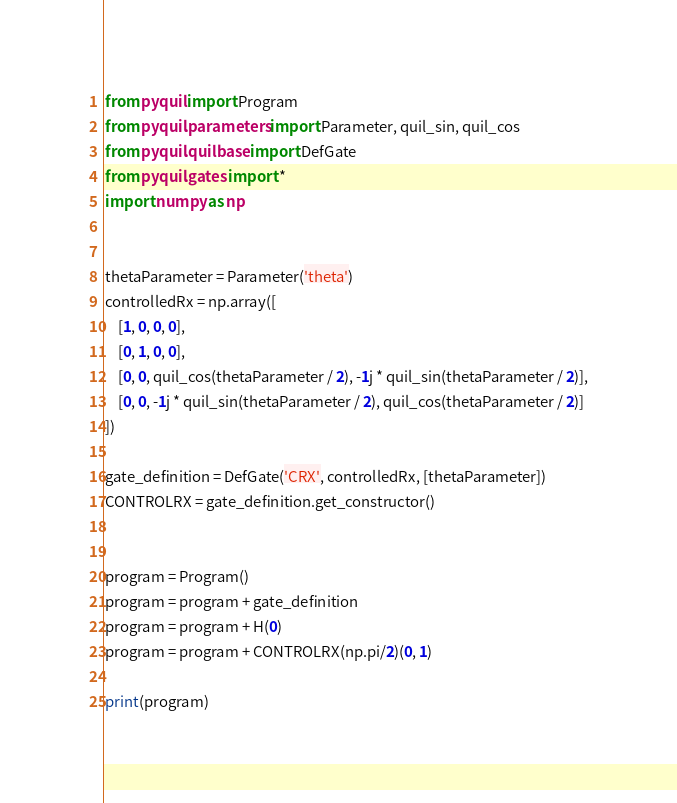Convert code to text. <code><loc_0><loc_0><loc_500><loc_500><_Python_>from pyquil import Program
from pyquil.parameters import Parameter, quil_sin, quil_cos
from pyquil.quilbase import DefGate
from pyquil.gates import *
import numpy as np


thetaParameter = Parameter('theta')
controlledRx = np.array([
    [1, 0, 0, 0],
    [0, 1, 0, 0],
    [0, 0, quil_cos(thetaParameter / 2), -1j * quil_sin(thetaParameter / 2)],
    [0, 0, -1j * quil_sin(thetaParameter / 2), quil_cos(thetaParameter / 2)]
])

gate_definition = DefGate('CRX', controlledRx, [thetaParameter])
CONTROLRX = gate_definition.get_constructor()


program = Program()
program = program + gate_definition
program = program + H(0)
program = program + CONTROLRX(np.pi/2)(0, 1)

print(program)</code> 